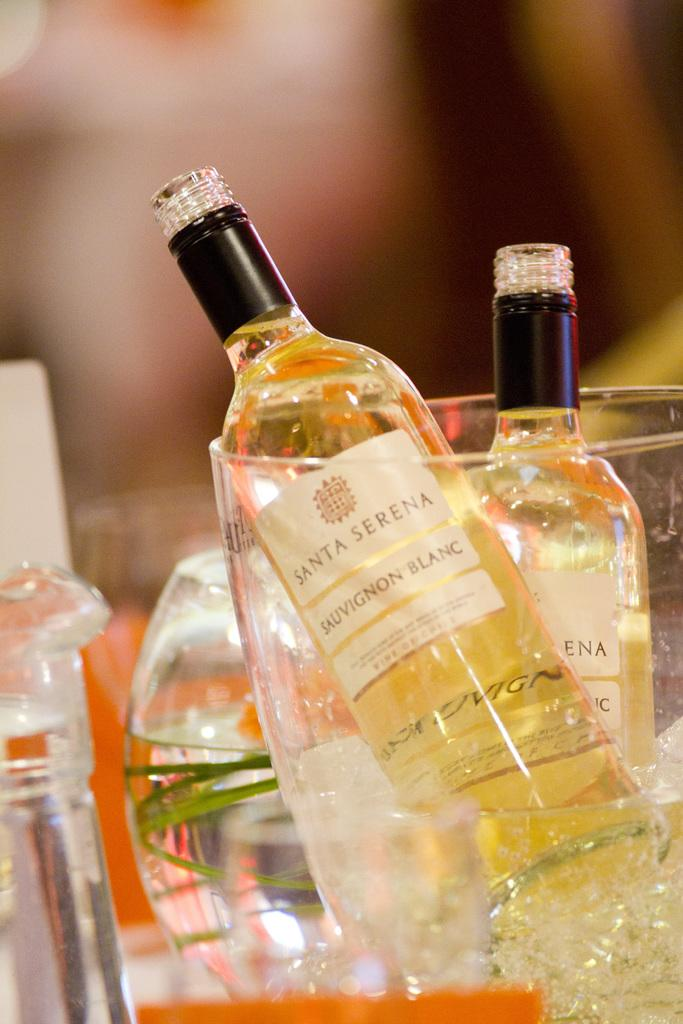<image>
Create a compact narrative representing the image presented. Two bottles of Santa Sierra wines are in a chilling jar in front of glasses. 